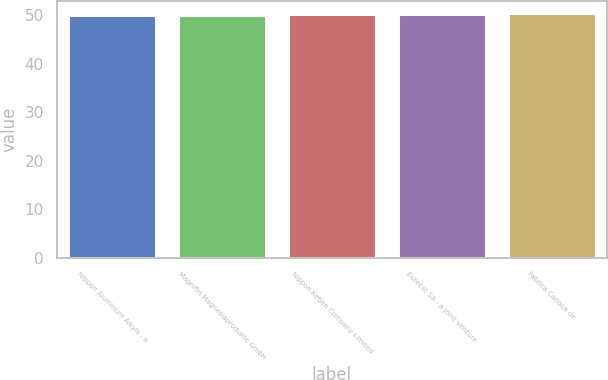Convert chart to OTSL. <chart><loc_0><loc_0><loc_500><loc_500><bar_chart><fcel>Nippon Aluminum Alkyls - a<fcel>Magnifin Magnesiaprodukte GmbH<fcel>Nippon Ketjen Company Limited<fcel>Eurecat SA - a joint venture<fcel>Fábrica Carioca de<nl><fcel>50<fcel>50.1<fcel>50.2<fcel>50.3<fcel>50.4<nl></chart> 